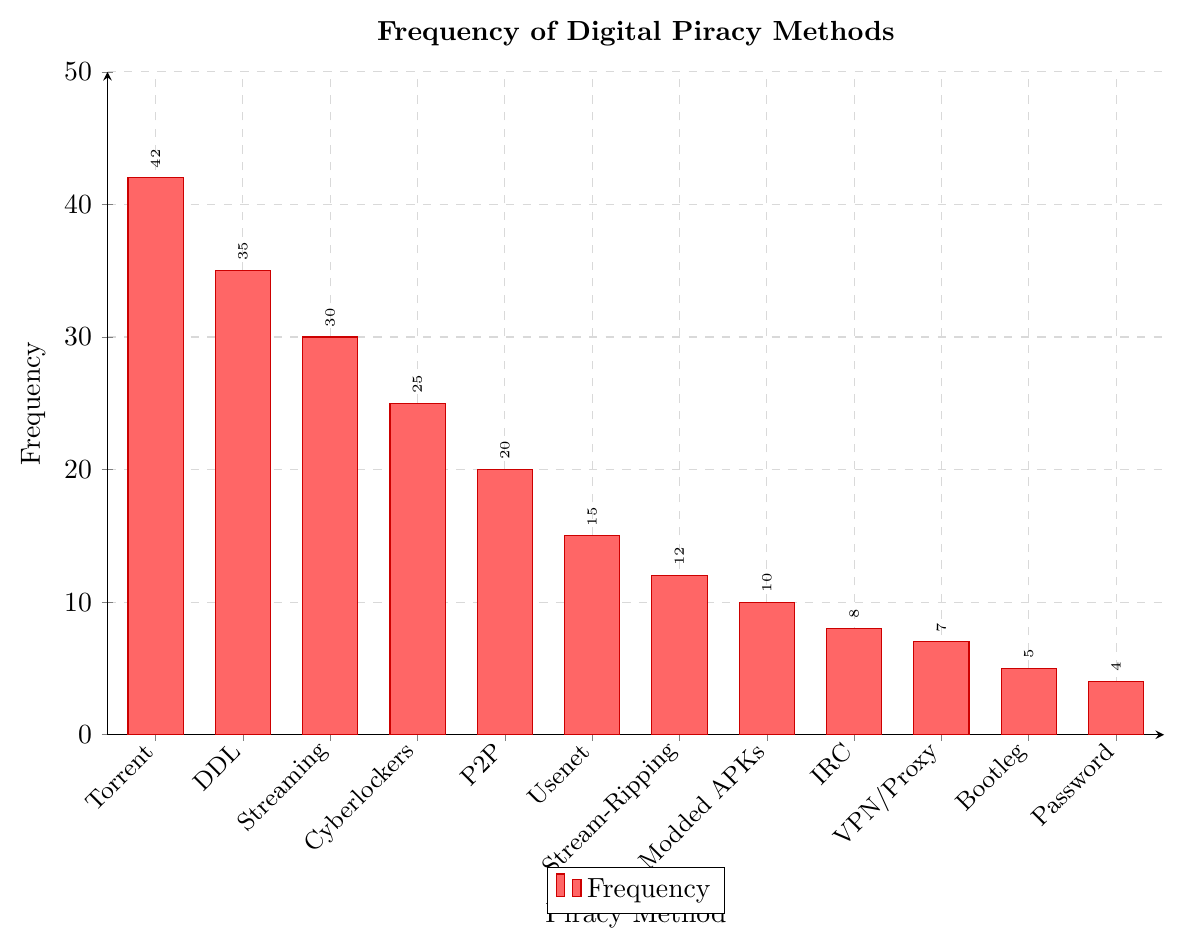Which piracy method has the highest frequency? The bar representing "Torrent File Sharing" is the tallest in the chart, indicating it has the highest frequency. Reading the value on the bar, it shows 42.
Answer: Torrent File Sharing Which piracy method has the lowest frequency? The shortest bar in the chart is for "Password Sharing," with a frequency of 4.
Answer: Password Sharing How much higher is the frequency of Torrent File Sharing compared to Bootleg Recording? The frequency of Torrent File Sharing is 42, and the frequency of Bootleg Recording is 5. The difference is calculated as 42 - 5 = 37.
Answer: 37 What is the sum of the frequencies for Direct Download Links (DDL) and Cyberlockers? The frequency for Direct Download Links (DDL) is 35 and Cyberlockers is 25. Adding these together gives 35 + 25 = 60.
Answer: 60 Which has a higher frequency, Stream-Ripping or Usenet? By comparing the bars, the frequency for Stream-Ripping is 12, while for Usenet it is 15. Usenet has a higher frequency.
Answer: Usenet What is the average frequency of Torrent File Sharing, Cyberlockers, and VPN/Proxy Server Bypassing? Adding the frequencies: Torrent (42), Cyberlockers (25), VPN/Proxy (7) gives a total of 42 + 25 + 7 = 74. There are 3 methods, so the average is 74 / 3 = 24.67.
Answer: 24.67 Are there more piracy methods with a frequency above 20 or below 20? Counting the bars: Above 20 are Torrent File Sharing (42), Direct Download Links (35), Streaming from Unauthorized Sites (30), Cyberlockers (25), and Peer-to-Peer Networks (20) = 5 methods. Below 20 are Usenet (15), Stream-Ripping (12), Modded APKs (10), IRC File Sharing (8), VPN/Proxy Server Bypassing (7), Bootleg Recording (5), Password Sharing (4) = 7 methods.
Answer: Below 20 What is the difference in frequency between Streaming from Unauthorized Sites and IRC File Sharing? The frequency for Streaming from Unauthorized Sites is 30 and for IRC File Sharing is 8. The difference is 30 - 8 = 22.
Answer: 22 Identify the method with exactly 15 frequencies. The bar corresponding to Usenet shows a frequency of 15.
Answer: Usenet Which methods have frequencies between 10 and 20 inclusive? The bars with frequencies between 10 and 20 are Peer-to-Peer Networks (20), Usenet (15), Stream-Ripping (12), and Modded APKs (10).
Answer: Peer-to-Peer Networks, Usenet, Stream-Ripping, Modded APKs 